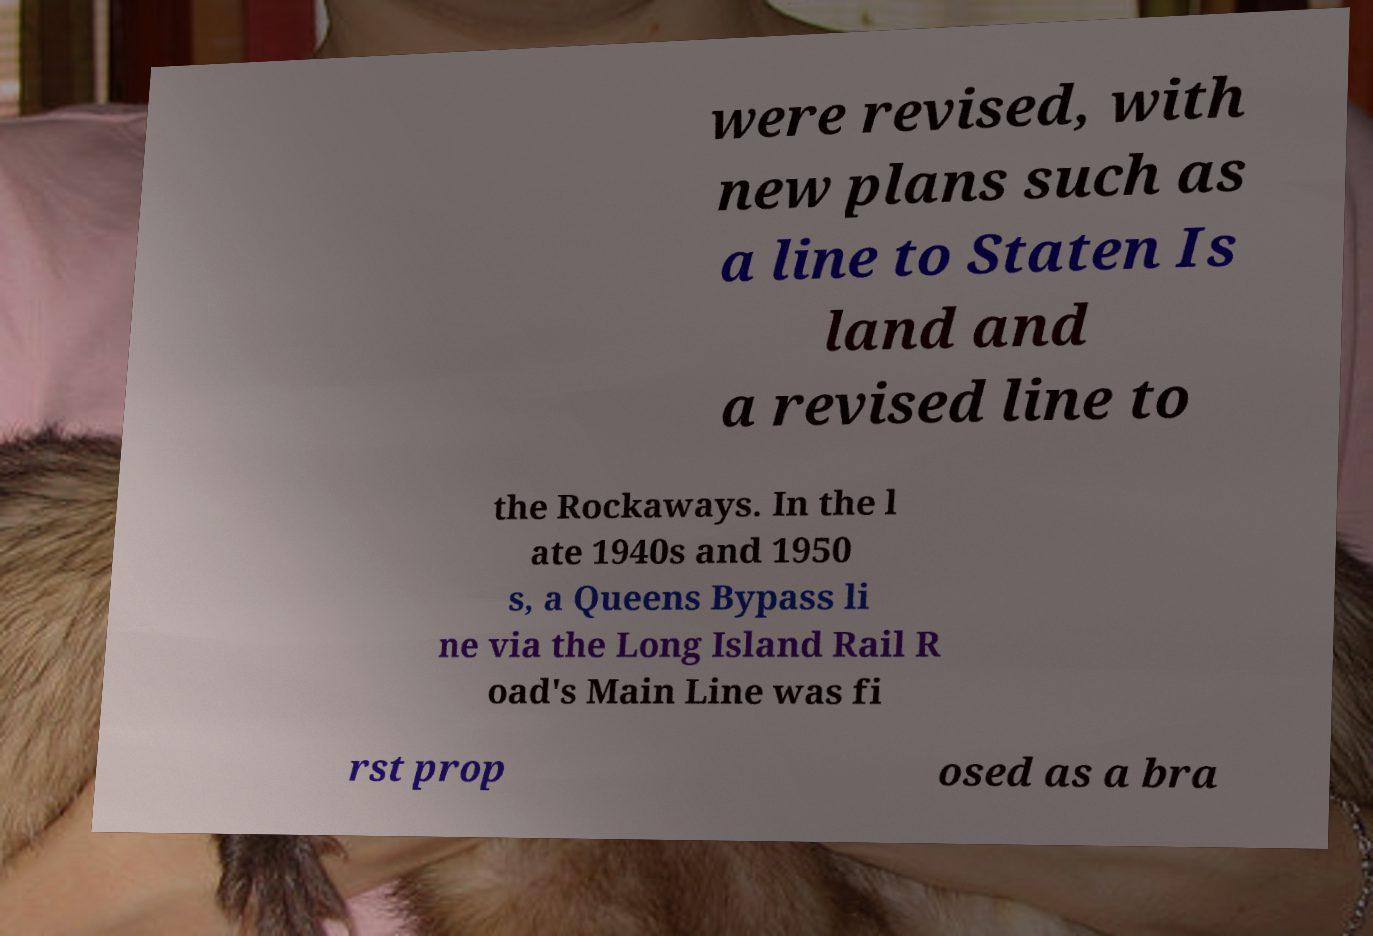There's text embedded in this image that I need extracted. Can you transcribe it verbatim? were revised, with new plans such as a line to Staten Is land and a revised line to the Rockaways. In the l ate 1940s and 1950 s, a Queens Bypass li ne via the Long Island Rail R oad's Main Line was fi rst prop osed as a bra 